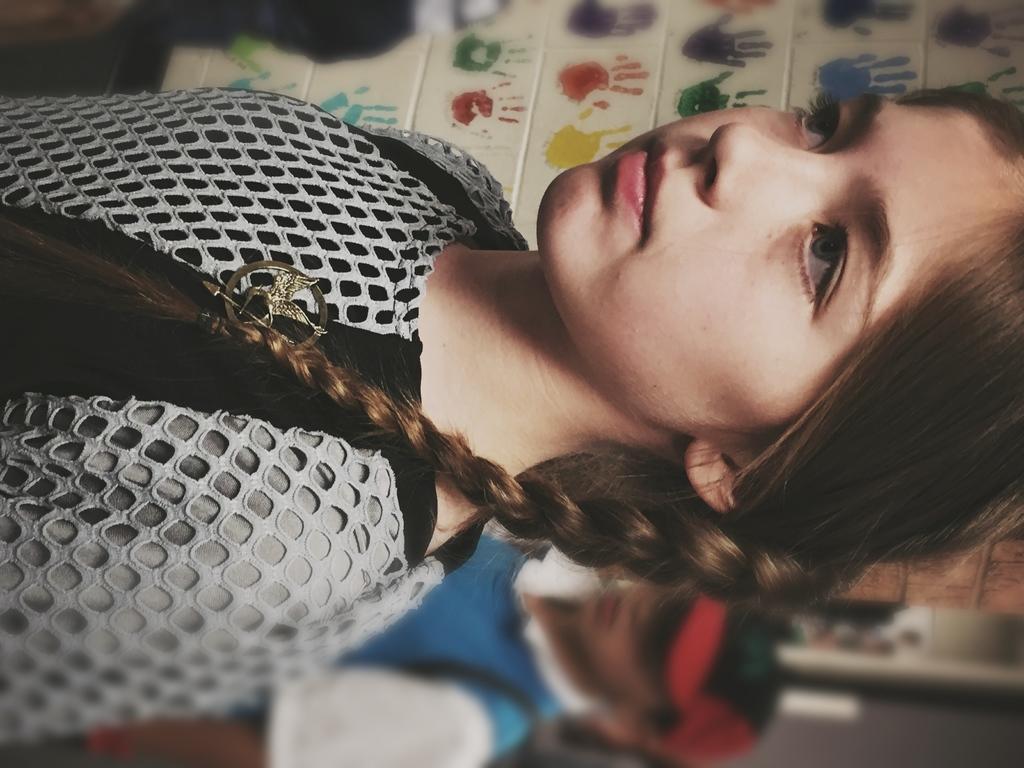Please provide a concise description of this image. In this image in front there is a girl. Behind her there is another person. In the background of the image there is a wall with fingerprints on it. 